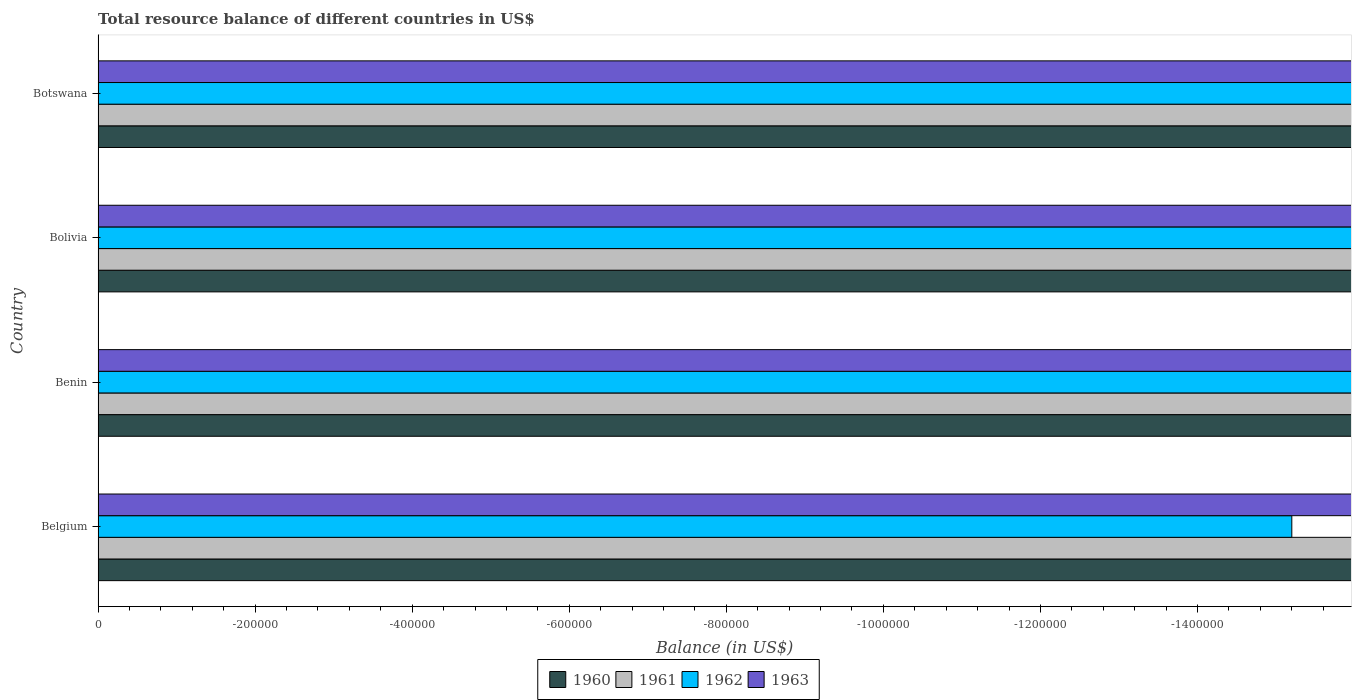How many bars are there on the 3rd tick from the top?
Provide a succinct answer. 0. How many bars are there on the 1st tick from the bottom?
Your response must be concise. 0. What is the label of the 4th group of bars from the top?
Your answer should be very brief. Belgium. In how many cases, is the number of bars for a given country not equal to the number of legend labels?
Your response must be concise. 4. What is the total resource balance in 1960 in Botswana?
Give a very brief answer. 0. What is the difference between the total resource balance in 1961 in Benin and the total resource balance in 1962 in Belgium?
Your answer should be very brief. 0. What is the average total resource balance in 1962 per country?
Your answer should be very brief. 0. Is it the case that in every country, the sum of the total resource balance in 1963 and total resource balance in 1960 is greater than the sum of total resource balance in 1961 and total resource balance in 1962?
Offer a very short reply. No. How many bars are there?
Offer a terse response. 0. Are all the bars in the graph horizontal?
Keep it short and to the point. Yes. What is the difference between two consecutive major ticks on the X-axis?
Offer a terse response. 2.00e+05. Are the values on the major ticks of X-axis written in scientific E-notation?
Ensure brevity in your answer.  No. Does the graph contain any zero values?
Your answer should be very brief. Yes. Does the graph contain grids?
Offer a terse response. No. Where does the legend appear in the graph?
Ensure brevity in your answer.  Bottom center. How many legend labels are there?
Ensure brevity in your answer.  4. What is the title of the graph?
Offer a terse response. Total resource balance of different countries in US$. What is the label or title of the X-axis?
Provide a short and direct response. Balance (in US$). What is the Balance (in US$) in 1961 in Benin?
Ensure brevity in your answer.  0. What is the Balance (in US$) of 1963 in Benin?
Make the answer very short. 0. What is the Balance (in US$) of 1962 in Bolivia?
Give a very brief answer. 0. What is the Balance (in US$) in 1960 in Botswana?
Provide a short and direct response. 0. What is the Balance (in US$) in 1962 in Botswana?
Your response must be concise. 0. What is the total Balance (in US$) in 1962 in the graph?
Your answer should be compact. 0. What is the total Balance (in US$) of 1963 in the graph?
Offer a very short reply. 0. 